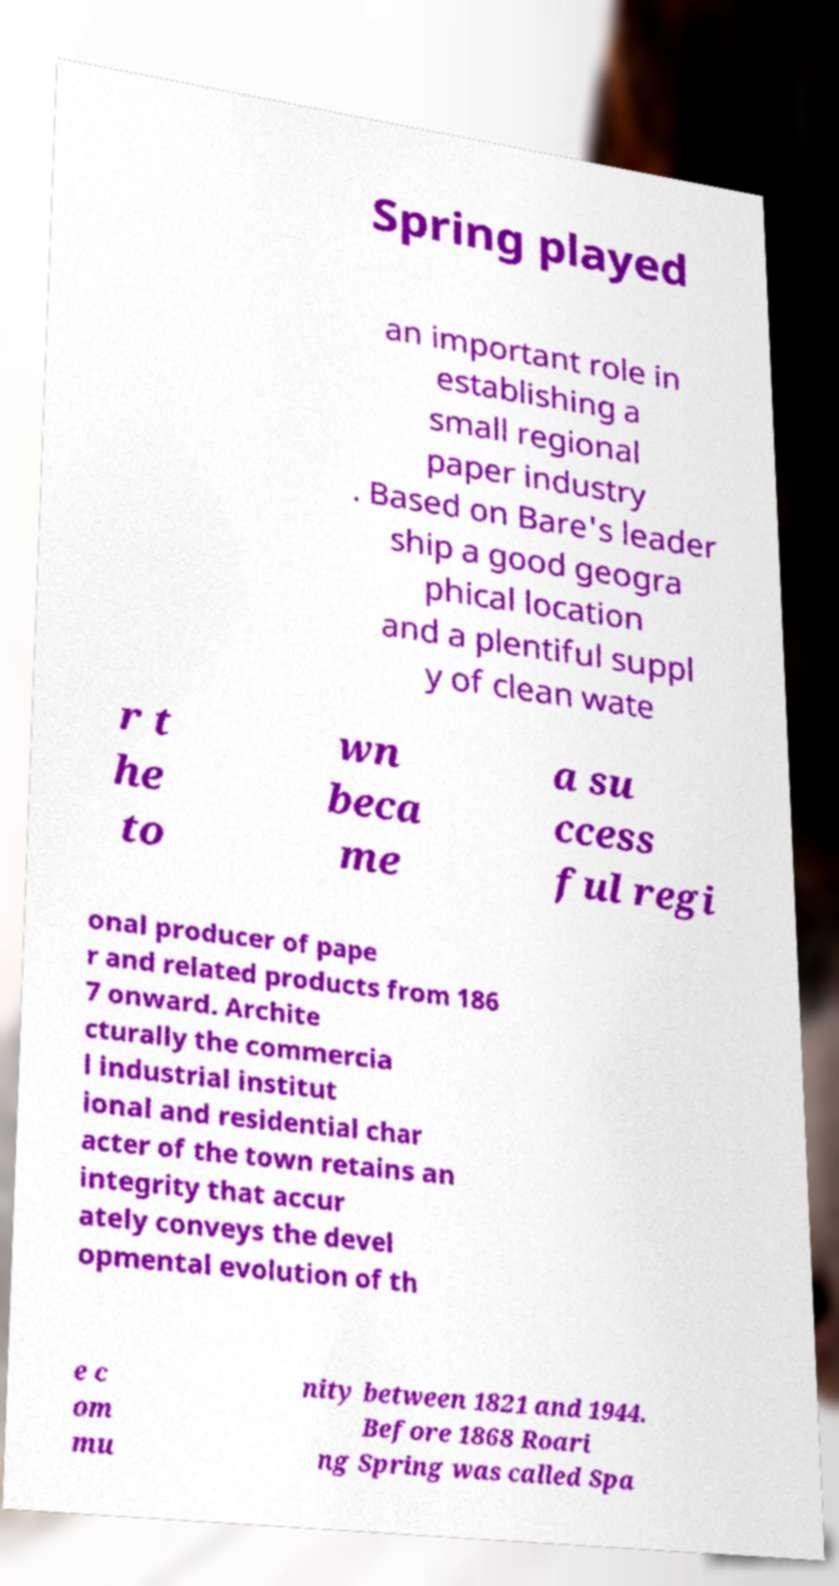Can you accurately transcribe the text from the provided image for me? Spring played an important role in establishing a small regional paper industry . Based on Bare's leader ship a good geogra phical location and a plentiful suppl y of clean wate r t he to wn beca me a su ccess ful regi onal producer of pape r and related products from 186 7 onward. Archite cturally the commercia l industrial institut ional and residential char acter of the town retains an integrity that accur ately conveys the devel opmental evolution of th e c om mu nity between 1821 and 1944. Before 1868 Roari ng Spring was called Spa 